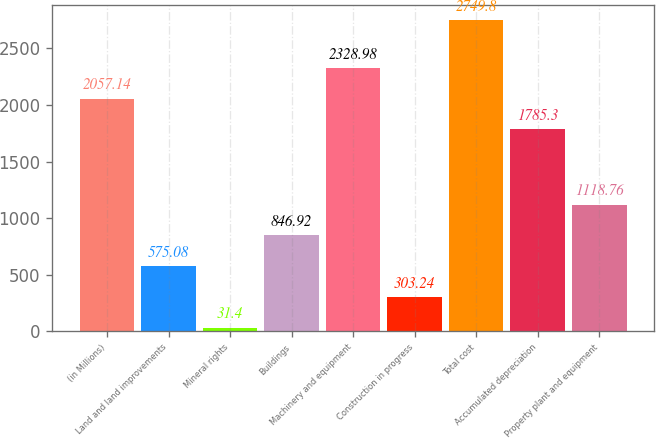Convert chart. <chart><loc_0><loc_0><loc_500><loc_500><bar_chart><fcel>(in Millions)<fcel>Land and land improvements<fcel>Mineral rights<fcel>Buildings<fcel>Machinery and equipment<fcel>Construction in progress<fcel>Total cost<fcel>Accumulated depreciation<fcel>Property plant and equipment<nl><fcel>2057.14<fcel>575.08<fcel>31.4<fcel>846.92<fcel>2328.98<fcel>303.24<fcel>2749.8<fcel>1785.3<fcel>1118.76<nl></chart> 